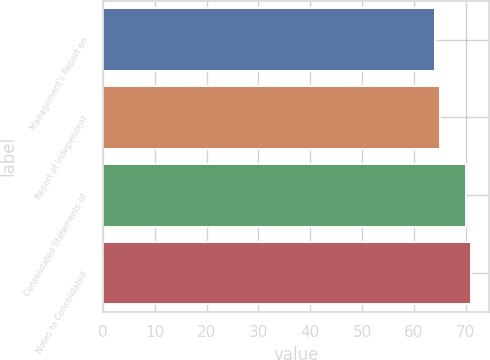Convert chart. <chart><loc_0><loc_0><loc_500><loc_500><bar_chart><fcel>Management's Report on<fcel>Report of Independent<fcel>Consolidated Statements of<fcel>Notes to Consolidated<nl><fcel>64<fcel>65<fcel>70<fcel>71<nl></chart> 